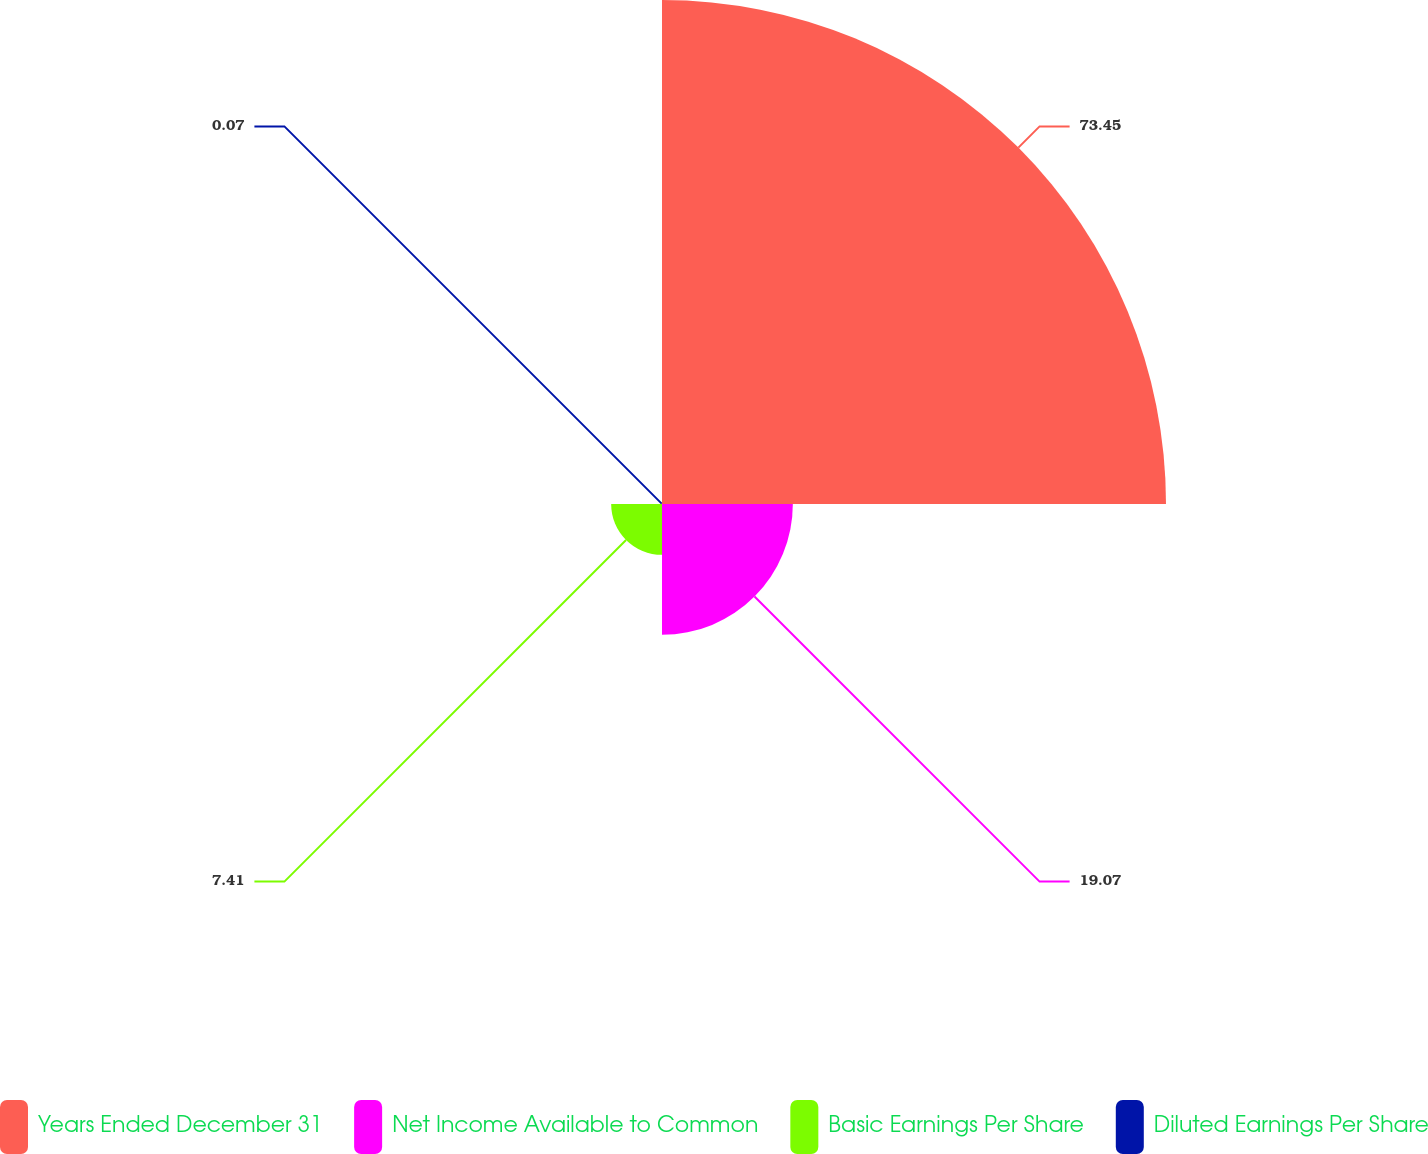Convert chart to OTSL. <chart><loc_0><loc_0><loc_500><loc_500><pie_chart><fcel>Years Ended December 31<fcel>Net Income Available to Common<fcel>Basic Earnings Per Share<fcel>Diluted Earnings Per Share<nl><fcel>73.46%<fcel>19.07%<fcel>7.41%<fcel>0.07%<nl></chart> 